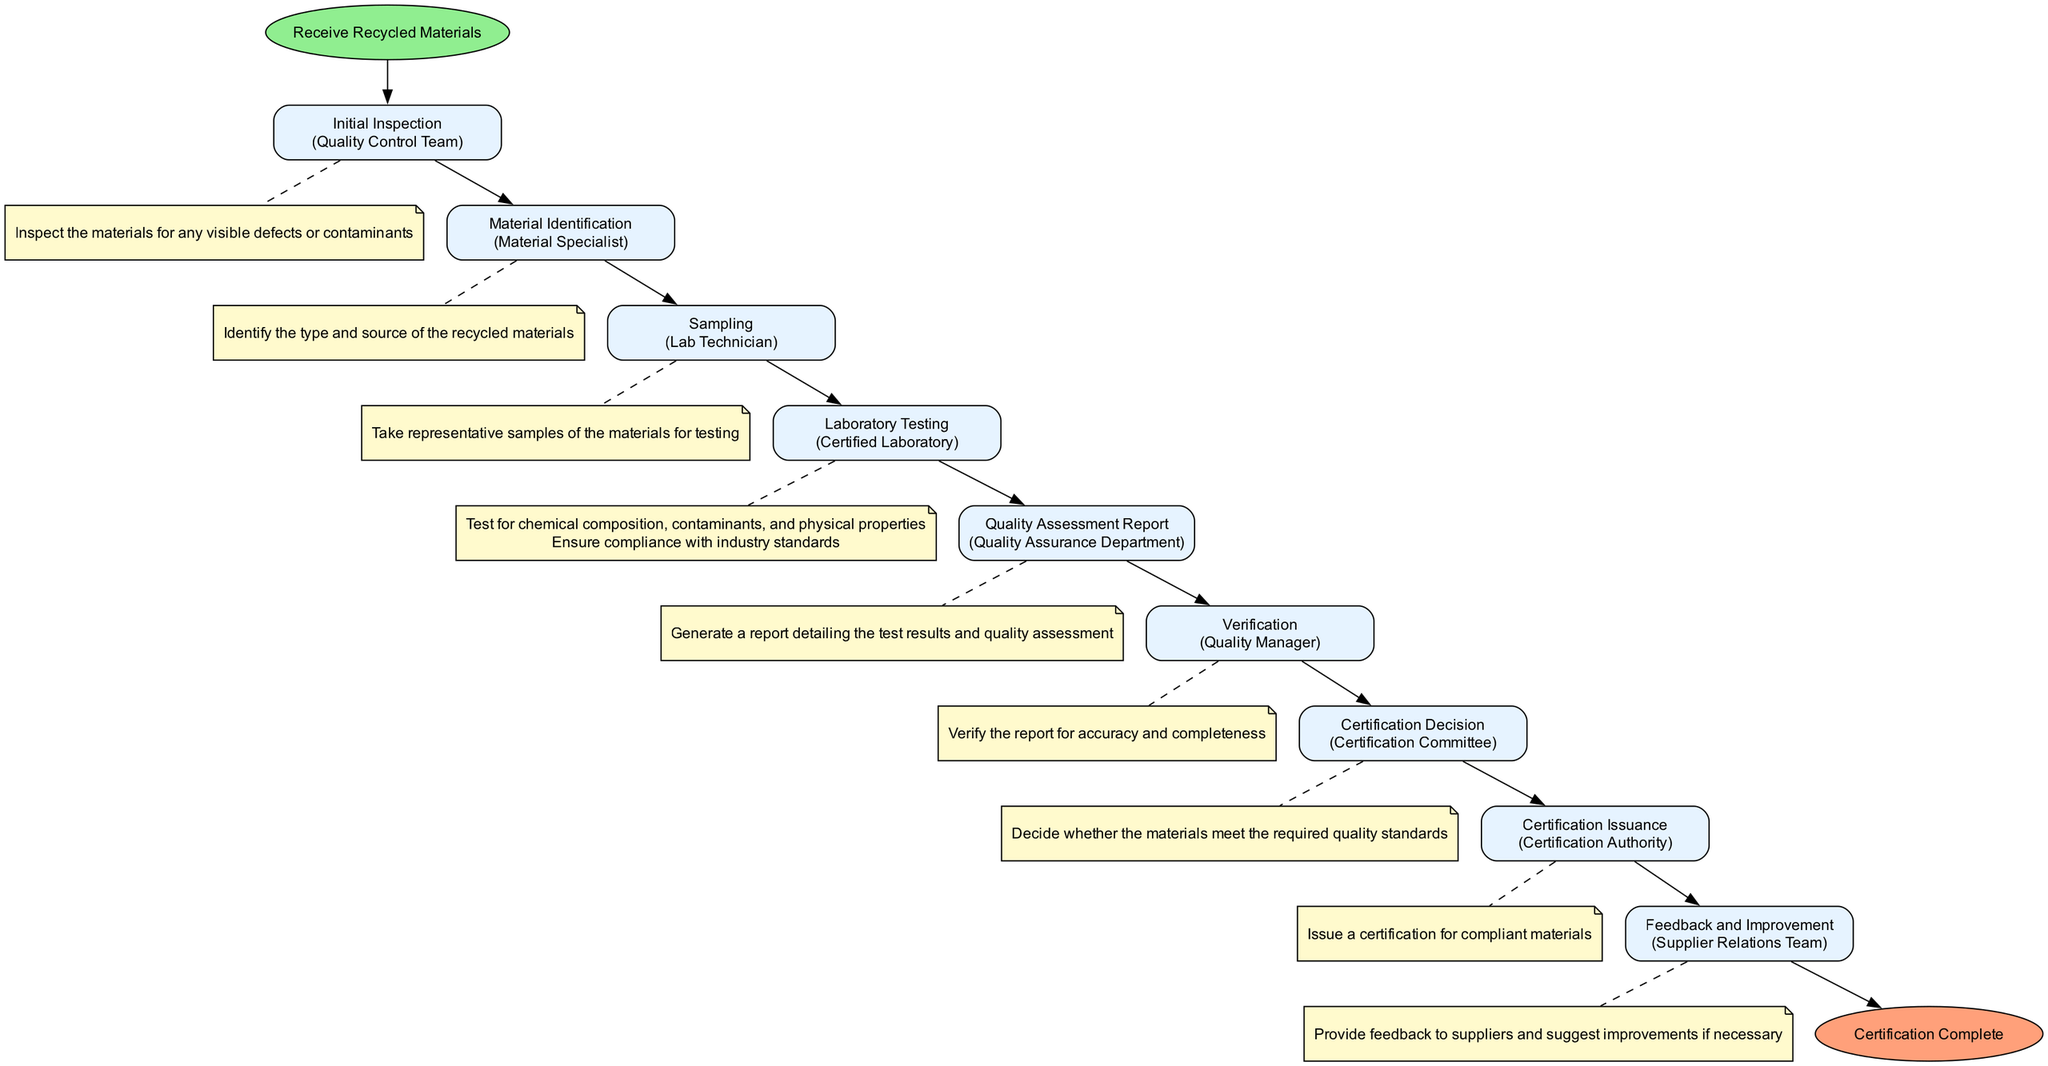What's the first step in the process? The first step is labeled "Initial Inspection," which can be identified as the first action that occurs after "Receive Recycled Materials."
Answer: Initial Inspection Who is responsible for the "Laboratory Testing" step? The responsible party for the "Laboratory Testing" step is clearly indicated as "Certified Laboratory" in the diagram.
Answer: Certified Laboratory How many steps are there in the process? The diagram lists a total of eight steps in the process, starting from "Initial Inspection" up to "Certification Issuance," excluding the start and end nodes.
Answer: Eight What comes directly after "Quality Assessment Report"? After generating the "Quality Assessment Report," the next step in the flow is "Verification," which is linked to the assessment's follow-up actions.
Answer: Verification Who provides feedback to suppliers? The "Supplier Relations Team" is the entity responsible for providing feedback and suggesting improvements based on the quality assessment results according to the diagram.
Answer: Supplier Relations Team What does the "Certification Decision" step determine? The "Certification Decision" step is designed to decide whether the materials meet the required quality standards, indicating a critical evaluation in the process.
Answer: Required quality standards How many parties are involved in the quality assessment process? The diagram indicates that six distinct parties are involved in the quality assessment process, including Quality Control Team, Material Specialist, Lab Technician, Certified Laboratory, Quality Assurance Department, Quality Manager, and Certification Committee.
Answer: Six What action follows "Sampling"? "Laboratory Testing" follows the "Sampling" step in the process, as indicated by the directional flow from one node to the next.
Answer: Laboratory Testing Which step leads directly to the "Certification Issuance"? The step leading directly to "Certification Issuance" is "Certification Decision," which determines compliance before issuing the certification.
Answer: Certification Decision 